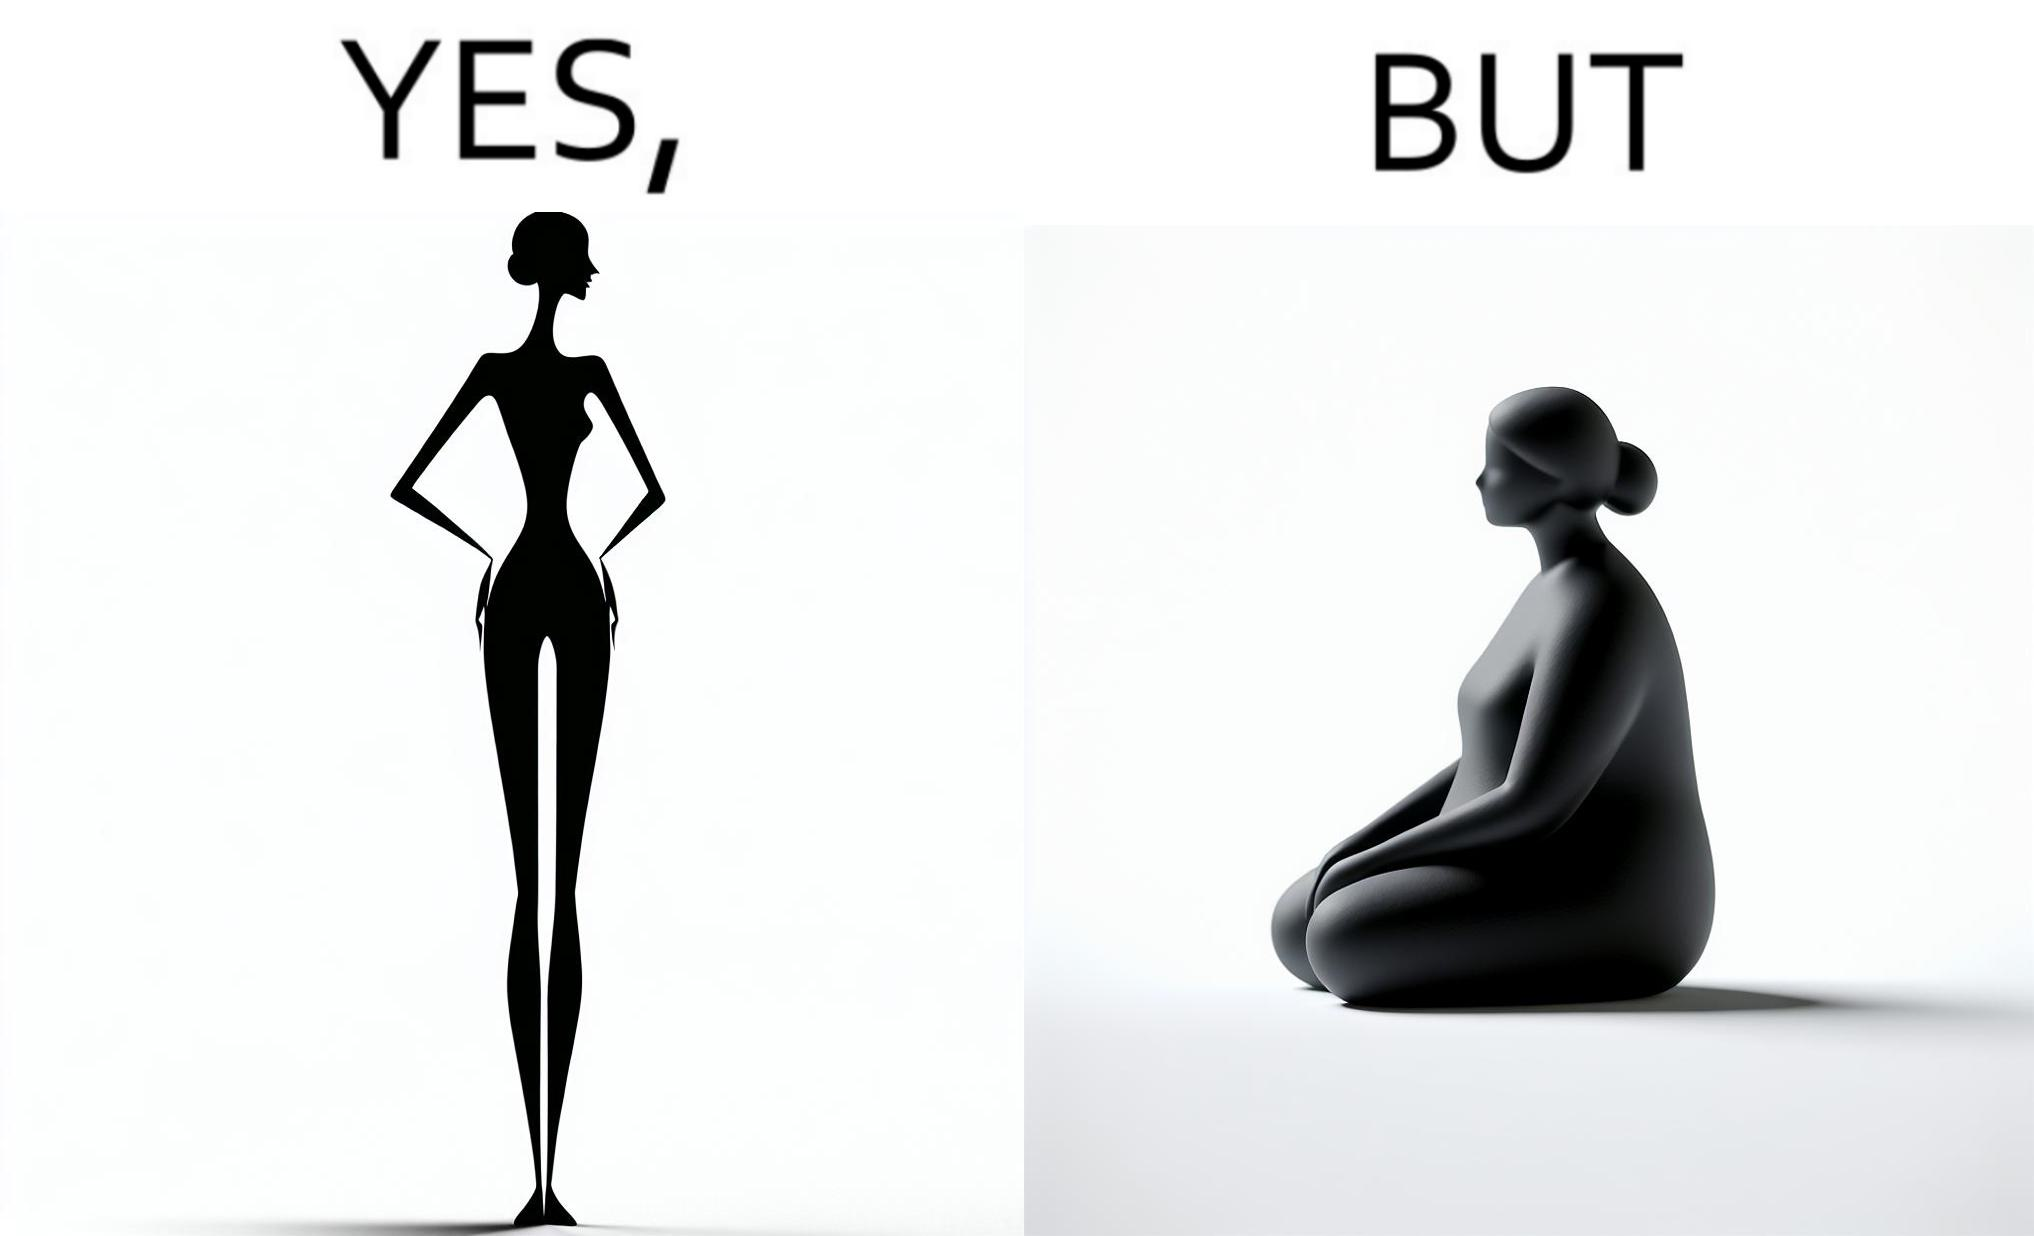Is this image satirical or non-satirical? Yes, this image is satirical. 